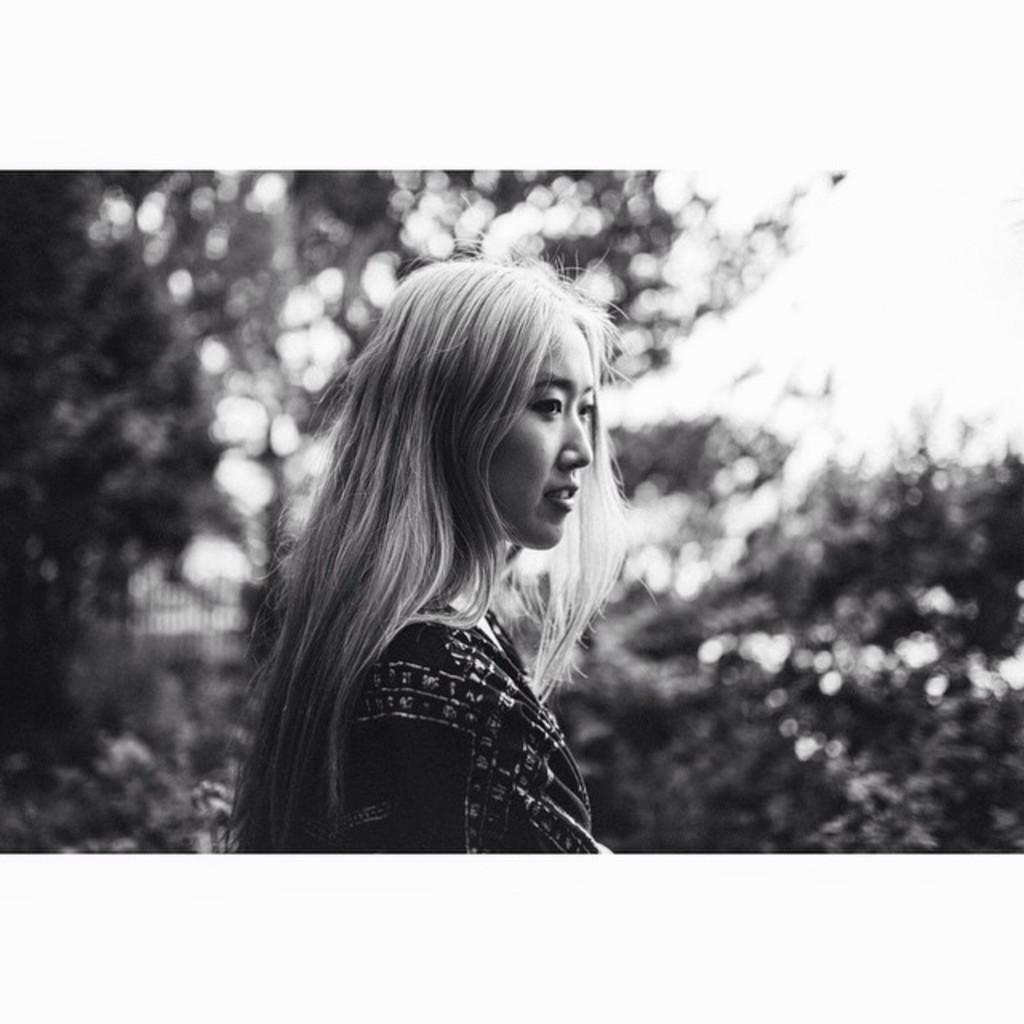What is the main subject of the image? There is a beautiful woman in the image. What is the woman wearing? The woman is wearing a dress. How is the image presented in terms of color? The image is in black and white. How many chairs are visible in the image? There are no chairs present in the image; it features a beautiful woman wearing a dress in black and white. 